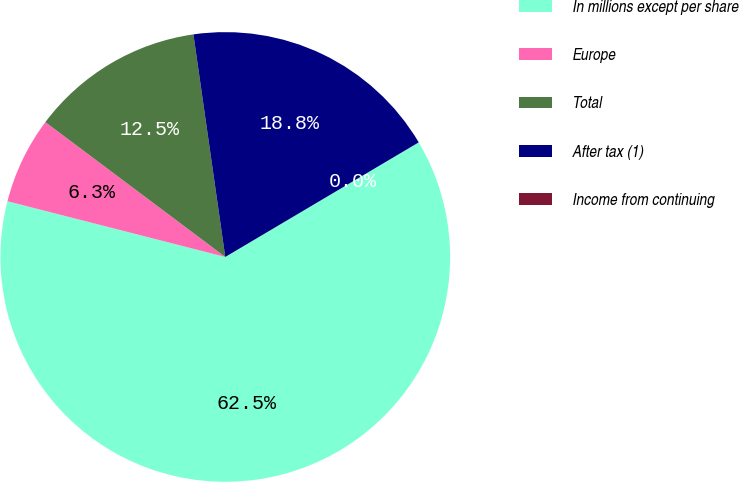Convert chart. <chart><loc_0><loc_0><loc_500><loc_500><pie_chart><fcel>In millions except per share<fcel>Europe<fcel>Total<fcel>After tax (1)<fcel>Income from continuing<nl><fcel>62.49%<fcel>6.25%<fcel>12.5%<fcel>18.75%<fcel>0.0%<nl></chart> 